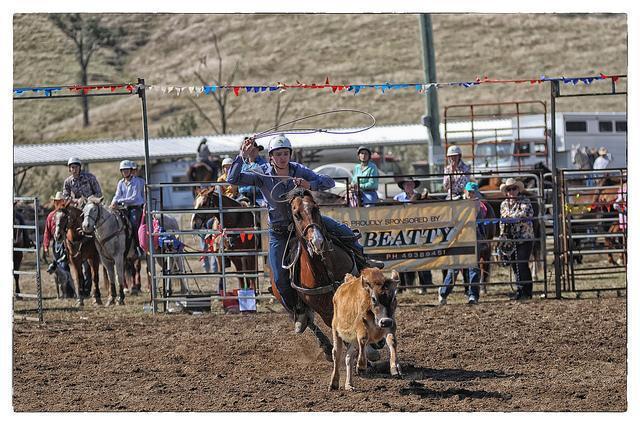How many different types of head coverings are people wearing?
Give a very brief answer. 2. How many horses are in the photo?
Give a very brief answer. 4. How many cows are there?
Give a very brief answer. 1. How many people can be seen?
Give a very brief answer. 2. How many benches are there?
Give a very brief answer. 0. 